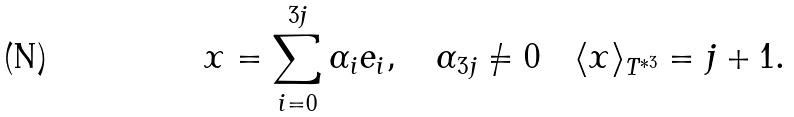Convert formula to latex. <formula><loc_0><loc_0><loc_500><loc_500>x = \sum _ { i = 0 } ^ { 3 j } \alpha _ { i } e _ { i } , \quad \alpha _ { 3 j } \neq 0 \quad \langle x \rangle _ { T ^ { * 3 } } = j + 1 .</formula> 